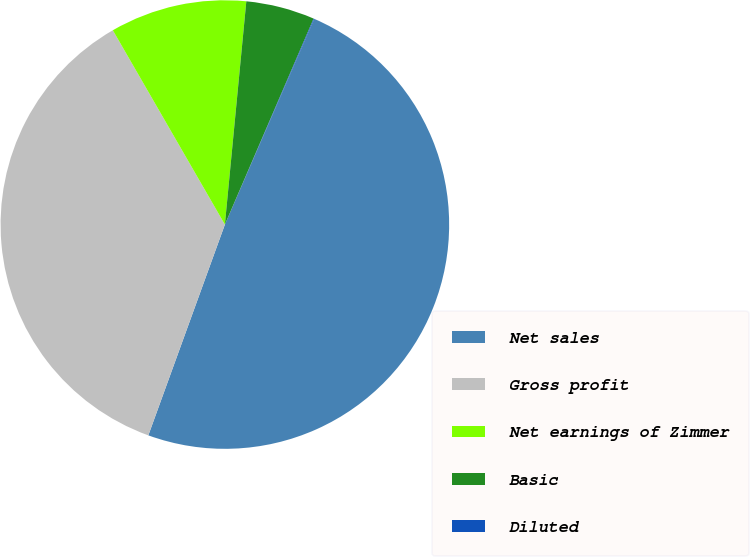<chart> <loc_0><loc_0><loc_500><loc_500><pie_chart><fcel>Net sales<fcel>Gross profit<fcel>Net earnings of Zimmer<fcel>Basic<fcel>Diluted<nl><fcel>49.02%<fcel>36.13%<fcel>9.85%<fcel>4.95%<fcel>0.05%<nl></chart> 